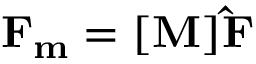Convert formula to latex. <formula><loc_0><loc_0><loc_500><loc_500>F _ { m } = [ M ] \hat { F }</formula> 